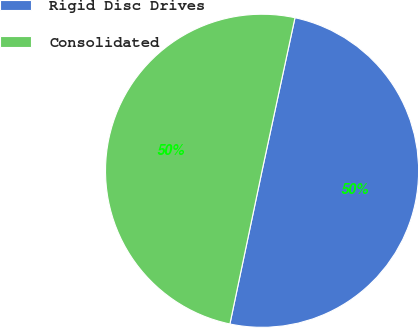Convert chart. <chart><loc_0><loc_0><loc_500><loc_500><pie_chart><fcel>Rigid Disc Drives<fcel>Consolidated<nl><fcel>49.92%<fcel>50.08%<nl></chart> 